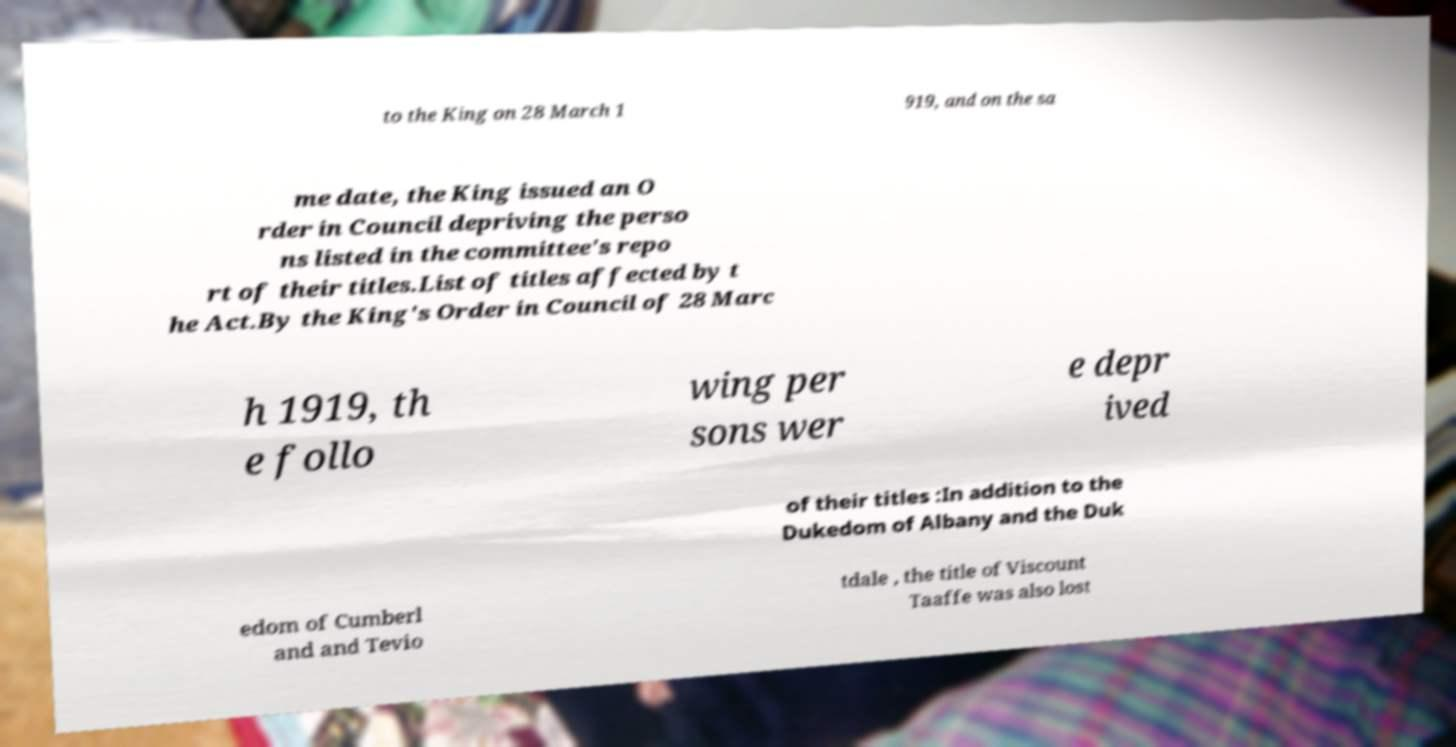Can you accurately transcribe the text from the provided image for me? to the King on 28 March 1 919, and on the sa me date, the King issued an O rder in Council depriving the perso ns listed in the committee's repo rt of their titles.List of titles affected by t he Act.By the King's Order in Council of 28 Marc h 1919, th e follo wing per sons wer e depr ived of their titles :In addition to the Dukedom of Albany and the Duk edom of Cumberl and and Tevio tdale , the title of Viscount Taaffe was also lost 